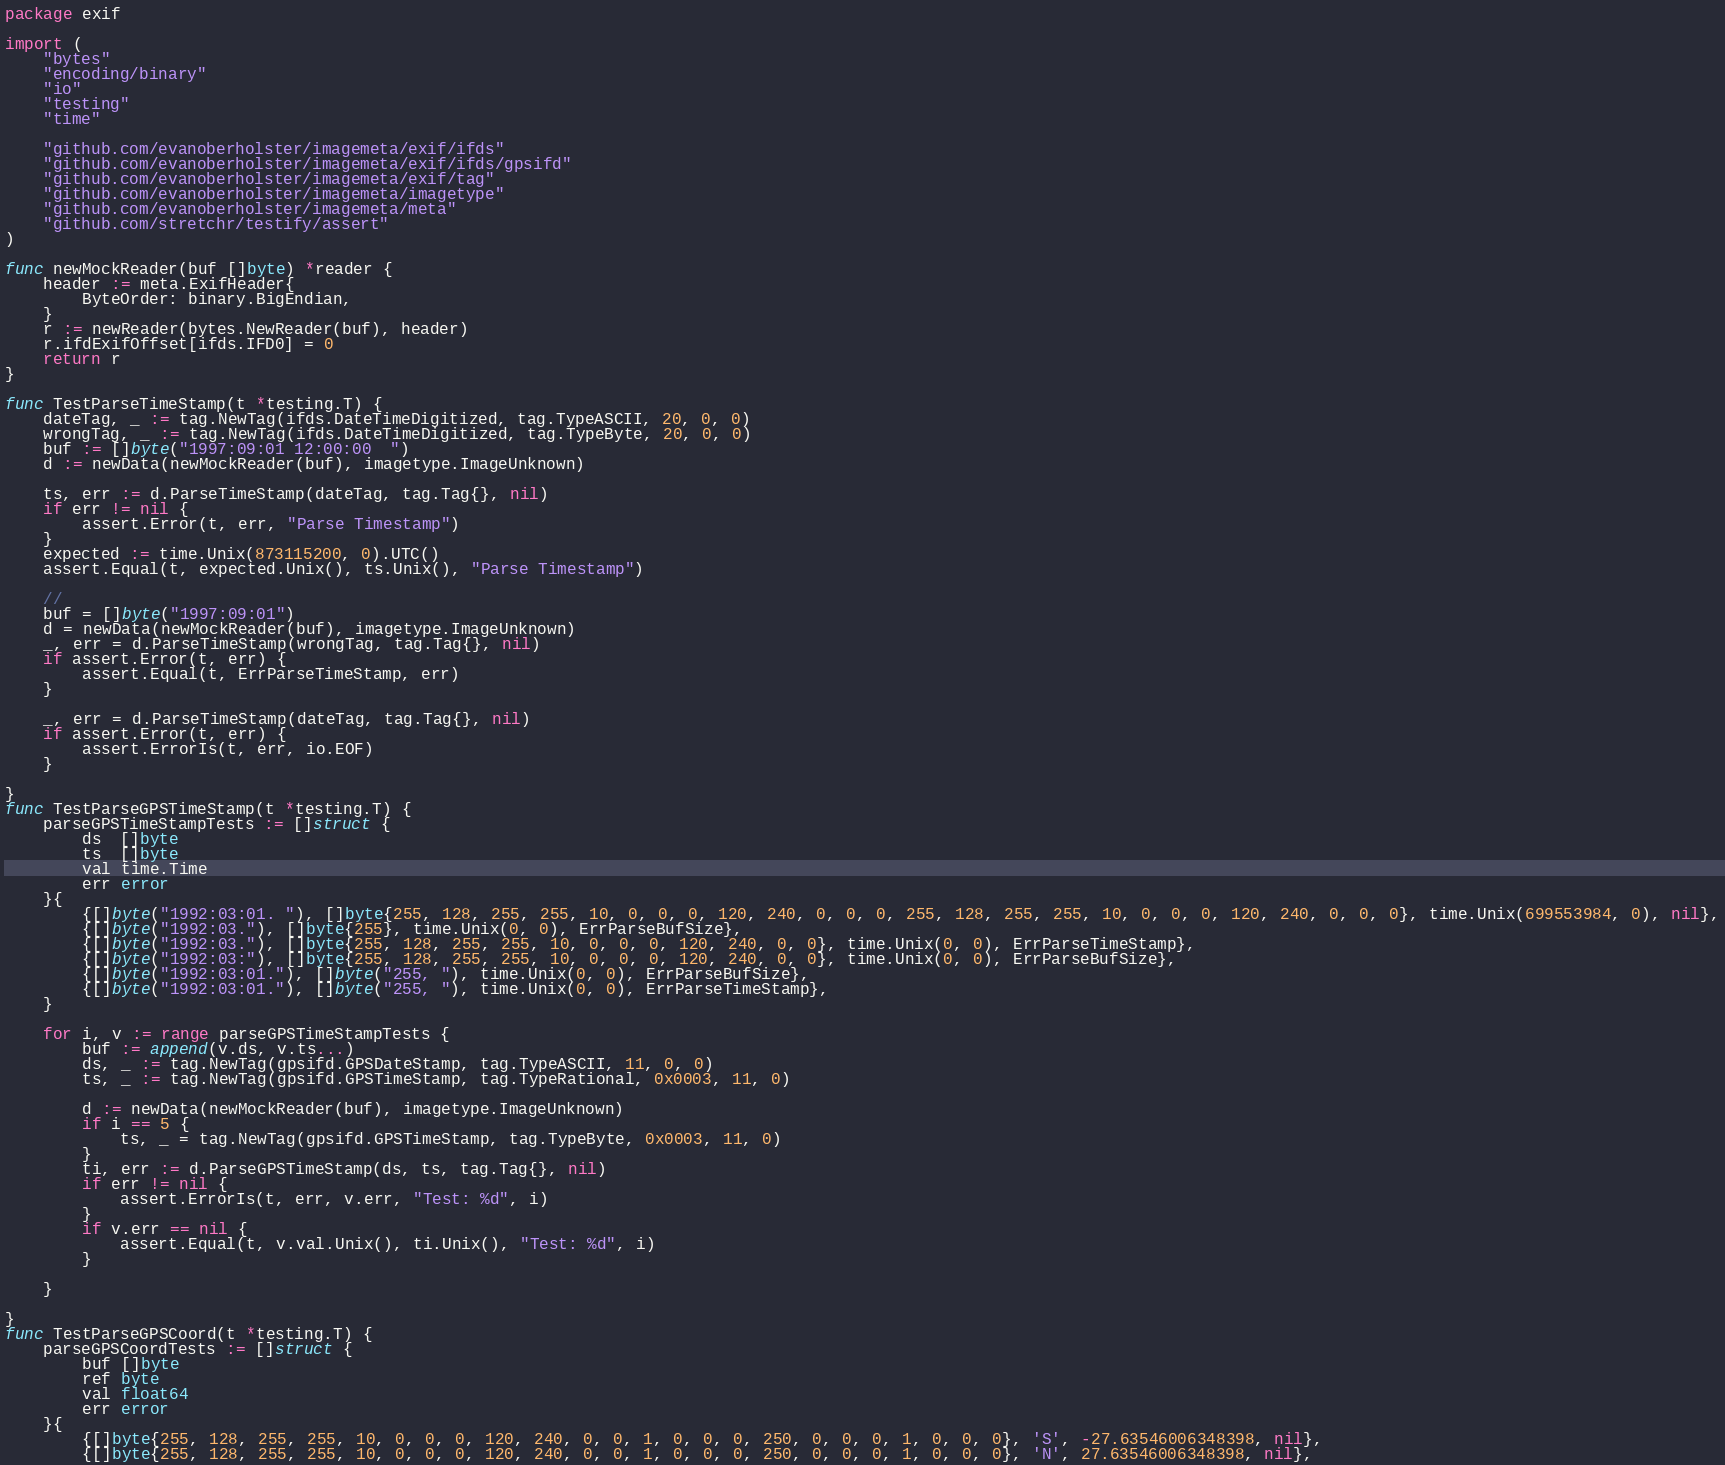<code> <loc_0><loc_0><loc_500><loc_500><_Go_>package exif

import (
	"bytes"
	"encoding/binary"
	"io"
	"testing"
	"time"

	"github.com/evanoberholster/imagemeta/exif/ifds"
	"github.com/evanoberholster/imagemeta/exif/ifds/gpsifd"
	"github.com/evanoberholster/imagemeta/exif/tag"
	"github.com/evanoberholster/imagemeta/imagetype"
	"github.com/evanoberholster/imagemeta/meta"
	"github.com/stretchr/testify/assert"
)

func newMockReader(buf []byte) *reader {
	header := meta.ExifHeader{
		ByteOrder: binary.BigEndian,
	}
	r := newReader(bytes.NewReader(buf), header)
	r.ifdExifOffset[ifds.IFD0] = 0
	return r
}

func TestParseTimeStamp(t *testing.T) {
	dateTag, _ := tag.NewTag(ifds.DateTimeDigitized, tag.TypeASCII, 20, 0, 0)
	wrongTag, _ := tag.NewTag(ifds.DateTimeDigitized, tag.TypeByte, 20, 0, 0)
	buf := []byte("1997:09:01 12:00:00  ")
	d := newData(newMockReader(buf), imagetype.ImageUnknown)

	ts, err := d.ParseTimeStamp(dateTag, tag.Tag{}, nil)
	if err != nil {
		assert.Error(t, err, "Parse Timestamp")
	}
	expected := time.Unix(873115200, 0).UTC()
	assert.Equal(t, expected.Unix(), ts.Unix(), "Parse Timestamp")

	//
	buf = []byte("1997:09:01")
	d = newData(newMockReader(buf), imagetype.ImageUnknown)
	_, err = d.ParseTimeStamp(wrongTag, tag.Tag{}, nil)
	if assert.Error(t, err) {
		assert.Equal(t, ErrParseTimeStamp, err)
	}

	_, err = d.ParseTimeStamp(dateTag, tag.Tag{}, nil)
	if assert.Error(t, err) {
		assert.ErrorIs(t, err, io.EOF)
	}

}
func TestParseGPSTimeStamp(t *testing.T) {
	parseGPSTimeStampTests := []struct {
		ds  []byte
		ts  []byte
		val time.Time
		err error
	}{
		{[]byte("1992:03:01. "), []byte{255, 128, 255, 255, 10, 0, 0, 0, 120, 240, 0, 0, 0, 255, 128, 255, 255, 10, 0, 0, 0, 120, 240, 0, 0, 0}, time.Unix(699553984, 0), nil},
		{[]byte("1992:03."), []byte{255}, time.Unix(0, 0), ErrParseBufSize},
		{[]byte("1992:03."), []byte{255, 128, 255, 255, 10, 0, 0, 0, 120, 240, 0, 0}, time.Unix(0, 0), ErrParseTimeStamp},
		{[]byte("1992:03:"), []byte{255, 128, 255, 255, 10, 0, 0, 0, 120, 240, 0, 0}, time.Unix(0, 0), ErrParseBufSize},
		{[]byte("1992:03:01."), []byte("255, "), time.Unix(0, 0), ErrParseBufSize},
		{[]byte("1992:03:01."), []byte("255, "), time.Unix(0, 0), ErrParseTimeStamp},
	}

	for i, v := range parseGPSTimeStampTests {
		buf := append(v.ds, v.ts...)
		ds, _ := tag.NewTag(gpsifd.GPSDateStamp, tag.TypeASCII, 11, 0, 0)
		ts, _ := tag.NewTag(gpsifd.GPSTimeStamp, tag.TypeRational, 0x0003, 11, 0)

		d := newData(newMockReader(buf), imagetype.ImageUnknown)
		if i == 5 {
			ts, _ = tag.NewTag(gpsifd.GPSTimeStamp, tag.TypeByte, 0x0003, 11, 0)
		}
		ti, err := d.ParseGPSTimeStamp(ds, ts, tag.Tag{}, nil)
		if err != nil {
			assert.ErrorIs(t, err, v.err, "Test: %d", i)
		}
		if v.err == nil {
			assert.Equal(t, v.val.Unix(), ti.Unix(), "Test: %d", i)
		}

	}

}
func TestParseGPSCoord(t *testing.T) {
	parseGPSCoordTests := []struct {
		buf []byte
		ref byte
		val float64
		err error
	}{
		{[]byte{255, 128, 255, 255, 10, 0, 0, 0, 120, 240, 0, 0, 1, 0, 0, 0, 250, 0, 0, 0, 1, 0, 0, 0}, 'S', -27.63546006348398, nil},
		{[]byte{255, 128, 255, 255, 10, 0, 0, 0, 120, 240, 0, 0, 1, 0, 0, 0, 250, 0, 0, 0, 1, 0, 0, 0}, 'N', 27.63546006348398, nil},</code> 